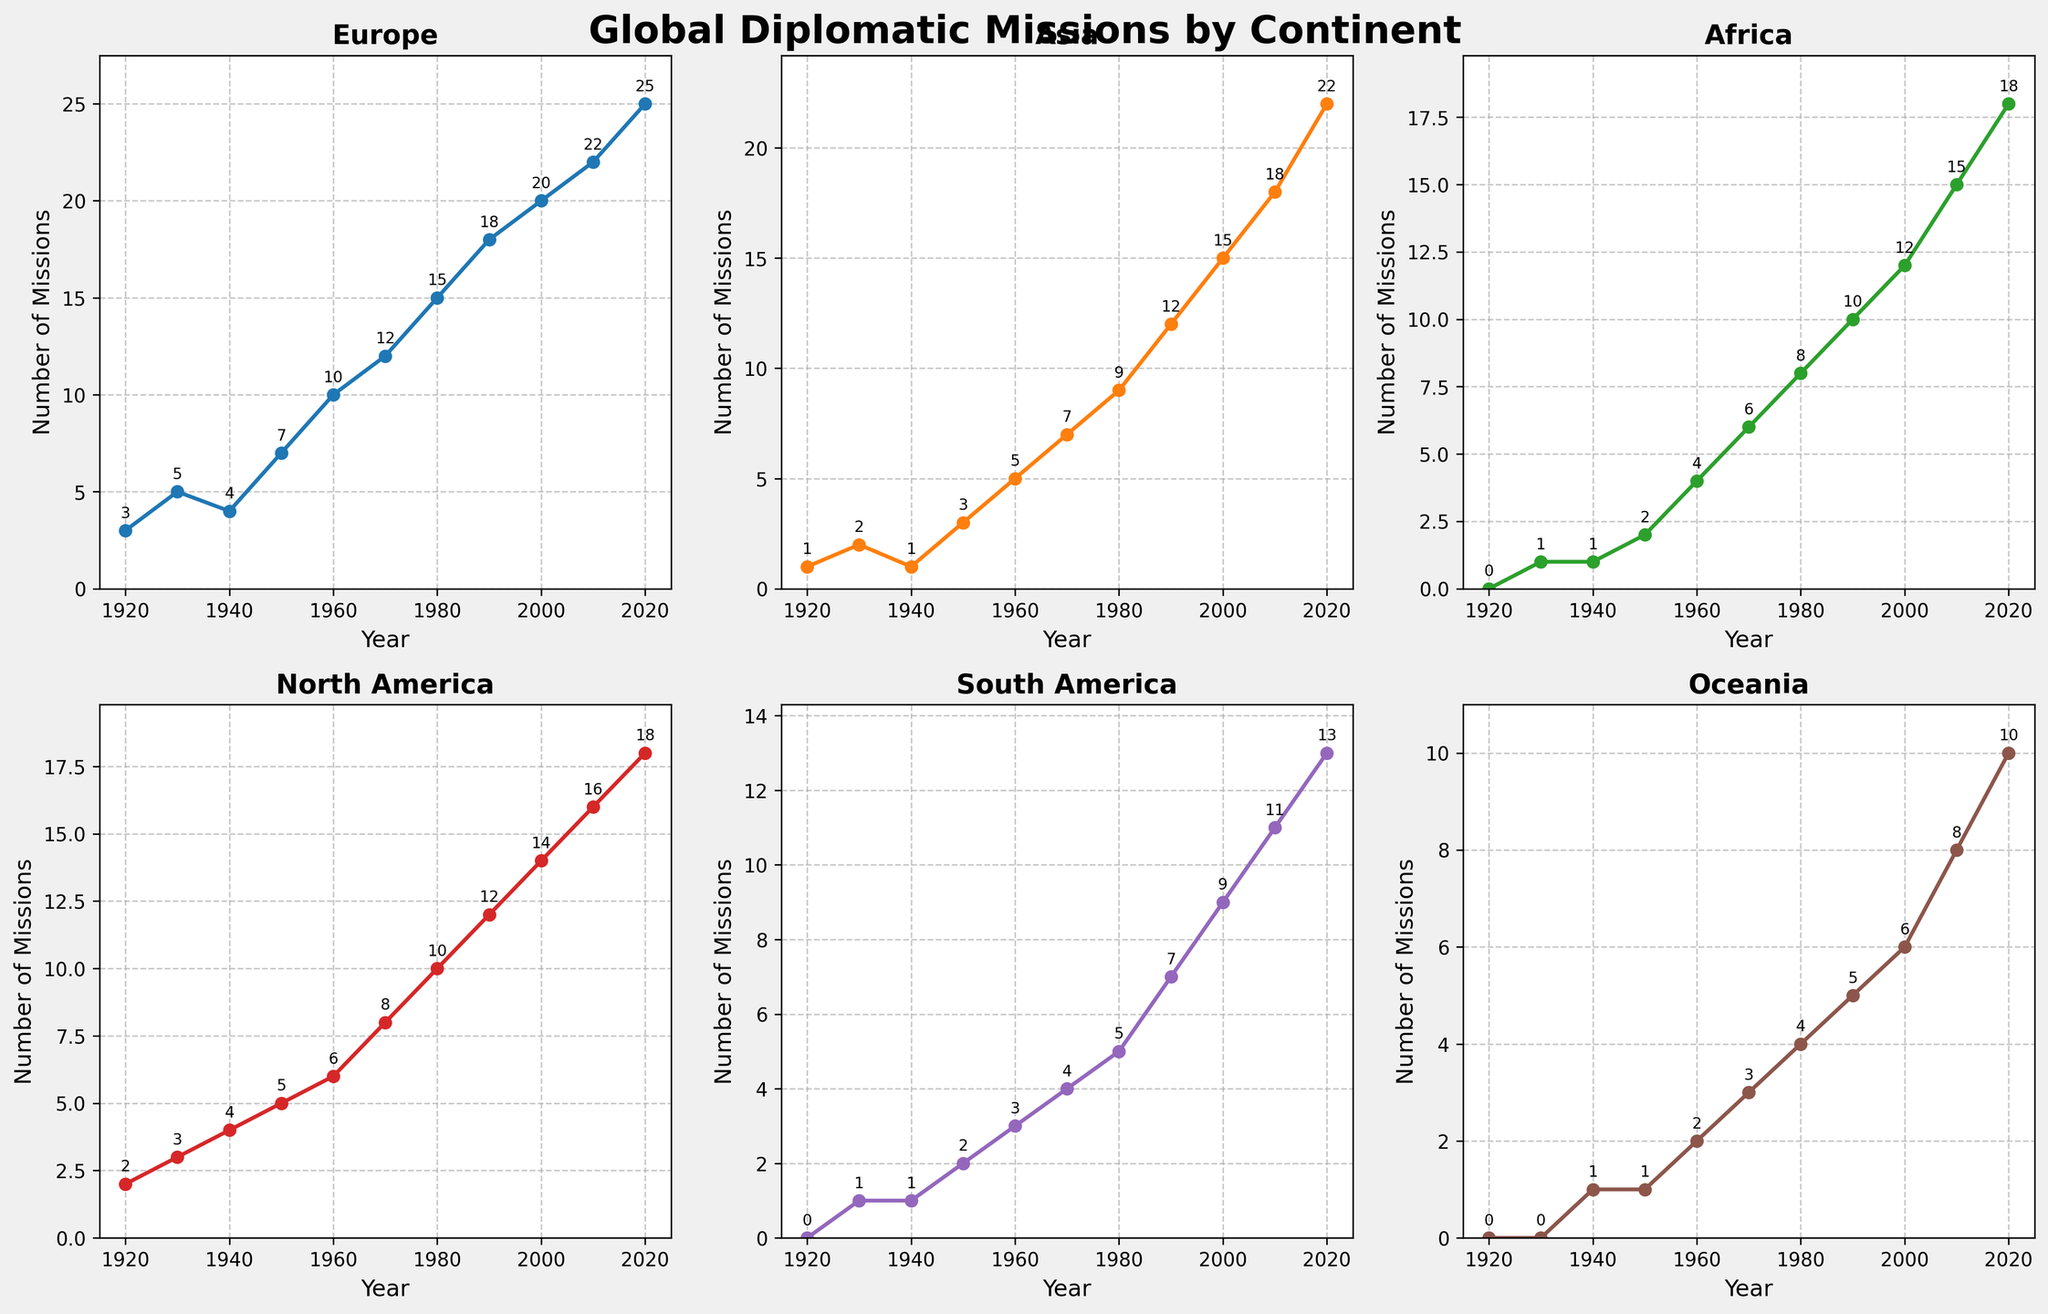What is the number of missions to Europe in 1960? The line for Europe has a point at 1960 with a label showing '10', indicating there were 10 missions to Europe in that year.
Answer: 10 Which continent had the highest number of missions in 2020? Looking at the points in 2020 for each of the continents, Europe has the highest value at 25.
Answer: Europe How many more missions were initiated in Oceania in 2020 compared to 1920? According to the 2020 data point for Oceania, there were 10 missions. In 1920, there were 0 missions. The difference is 10 - 0 = 10.
Answer: 10 In which decade did the royal family's diplomatic missions to Africa first reach double digits? Observing the point values for Africa, in the 1990s the number of missions was 10, which is the first occurrence of a double-digit value.
Answer: 1990s What is the average number of missions to Asia from 2000 to 2020? From the plot, the number of missions to Asia in 2000, 2010, and 2020 are 15, 18, and 22 respectively. The average is calculated as (15 + 18 + 22) / 3 = 55 / 3 ≈ 18.33
Answer: 18.33 Which continent saw the largest increase in missions from 2010 to 2020? Comparing the figures for each continent in 2010 and 2020, the increases are as follows: Europe (22 to 25, increase by 3), Asia (18 to 22, increase by 4), Africa (15 to 18, increase by 3), North America (16 to 18, increase by 2), South America (11 to 13, increase by 2), Oceania (8 to 10, increase by 2). Asia saw the largest increase by 4 missions.
Answer: Asia How many total missions were initiated across all continents in 1950? Summing up the 1950 values across all continents: Europe (7), Asia (3), Africa (2), North America (5), South America (2), Oceania (1), the total is 7 + 3 + 2 + 5 + 2 + 1 = 20.
Answer: 20 Which continent had consistent growth in the number of missions every decade? From analyzing the slopes of each line, Europe consistently increases its number of missions every decade from 1920 to 2020.
Answer: Europe Between 1930 and 1940, which continent experienced the smallest change in their number of missions? Europe (5 to 4, change by -1), Asia (2 to 1, change by -1), Africa (1 to 1, change by 0), North America (3 to 4, change by +1), South America (1 to 1, change by 0), Oceania (0 to 1, change by +1). Both Africa and South America experienced the smallest change with no change at all.
Answer: Africa and South America 